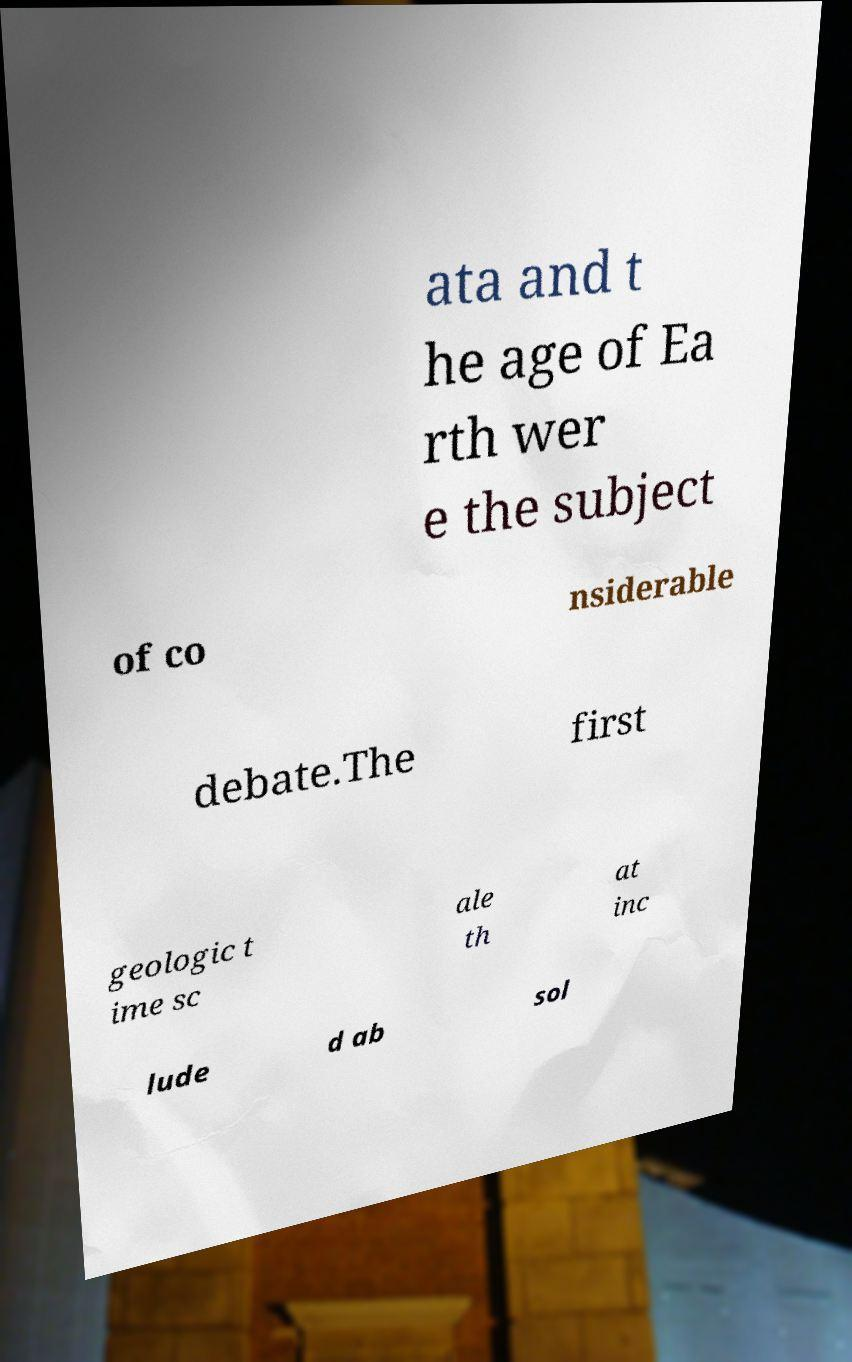What messages or text are displayed in this image? I need them in a readable, typed format. ata and t he age of Ea rth wer e the subject of co nsiderable debate.The first geologic t ime sc ale th at inc lude d ab sol 